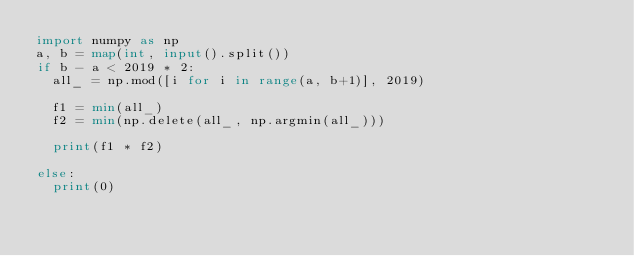Convert code to text. <code><loc_0><loc_0><loc_500><loc_500><_Python_>import numpy as np
a, b = map(int, input().split())
if b - a < 2019 * 2:
  all_ = np.mod([i for i in range(a, b+1)], 2019)

  f1 = min(all_)
  f2 = min(np.delete(all_, np.argmin(all_)))

  print(f1 * f2)
  
else:
  print(0)</code> 